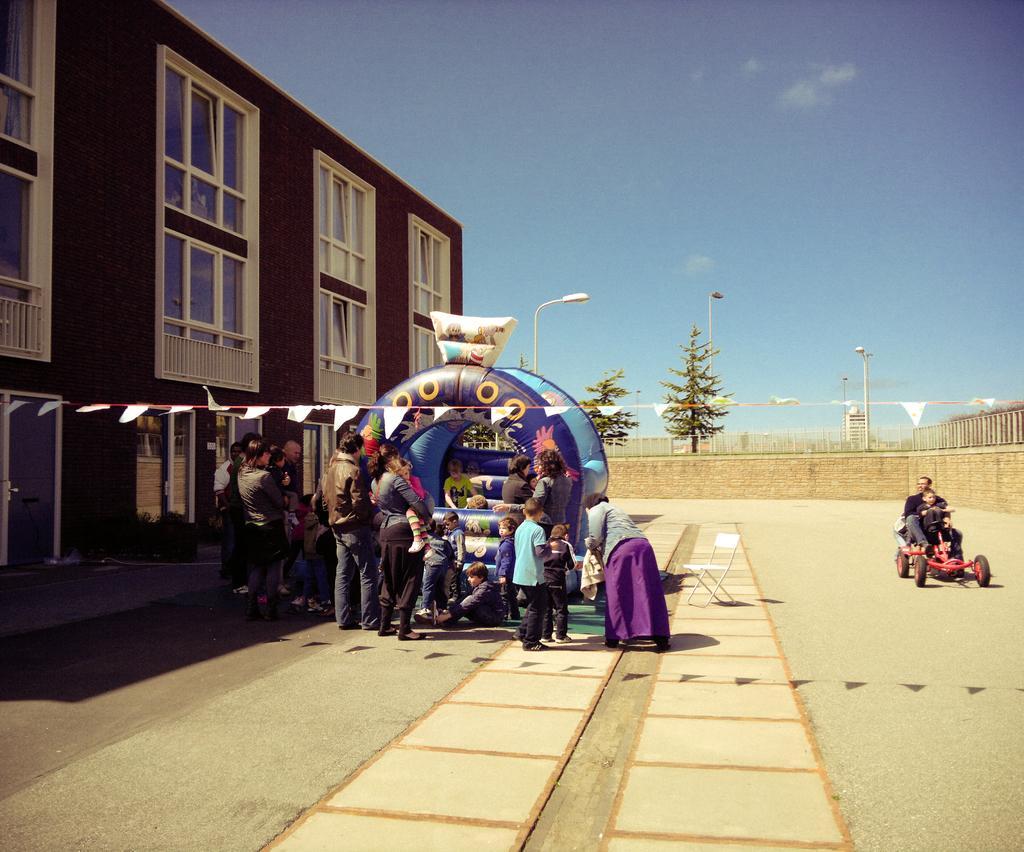Please provide a concise description of this image. In this picture there are group of people standing and there is an inflatable and there is a chair. On the right side of the image there are two persons sitting on the vehicle. On the left side of the image there is a building. At the back there are trees and poles and there is a railing on the wall. At the top there is sky and there are clouds. 